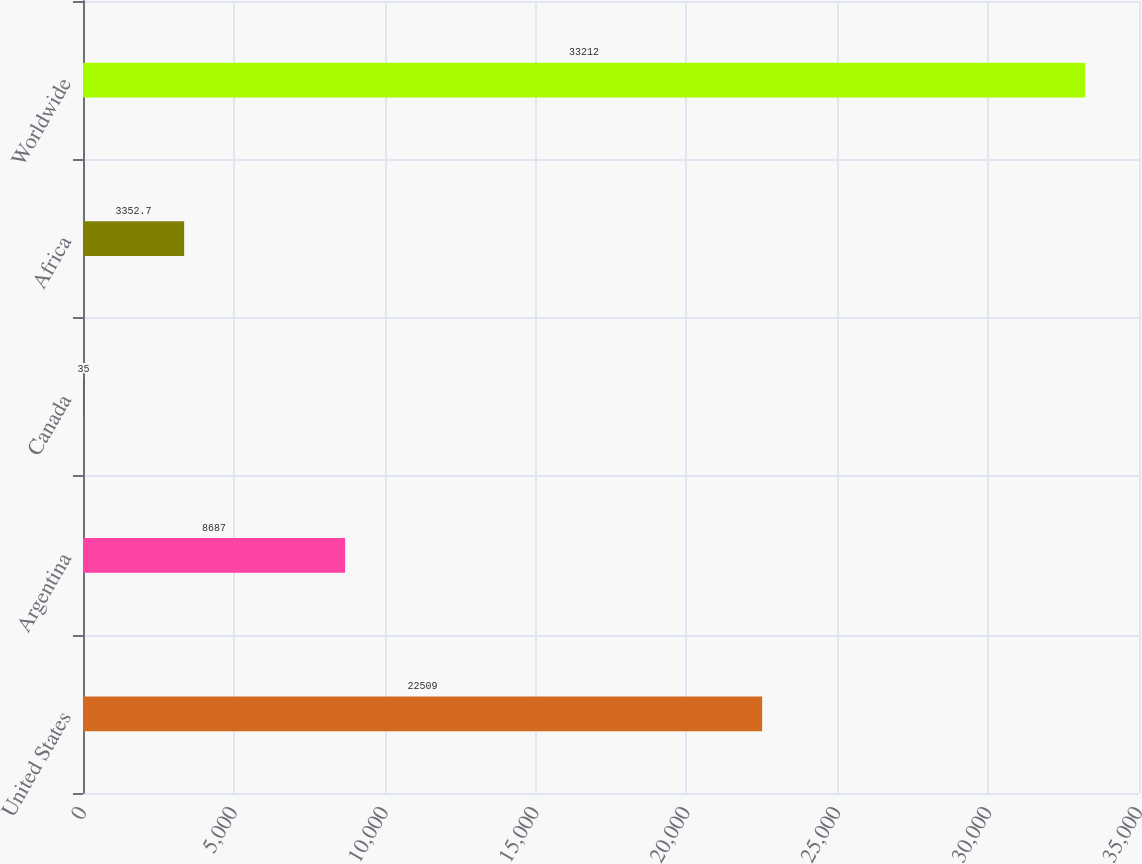Convert chart. <chart><loc_0><loc_0><loc_500><loc_500><bar_chart><fcel>United States<fcel>Argentina<fcel>Canada<fcel>Africa<fcel>Worldwide<nl><fcel>22509<fcel>8687<fcel>35<fcel>3352.7<fcel>33212<nl></chart> 